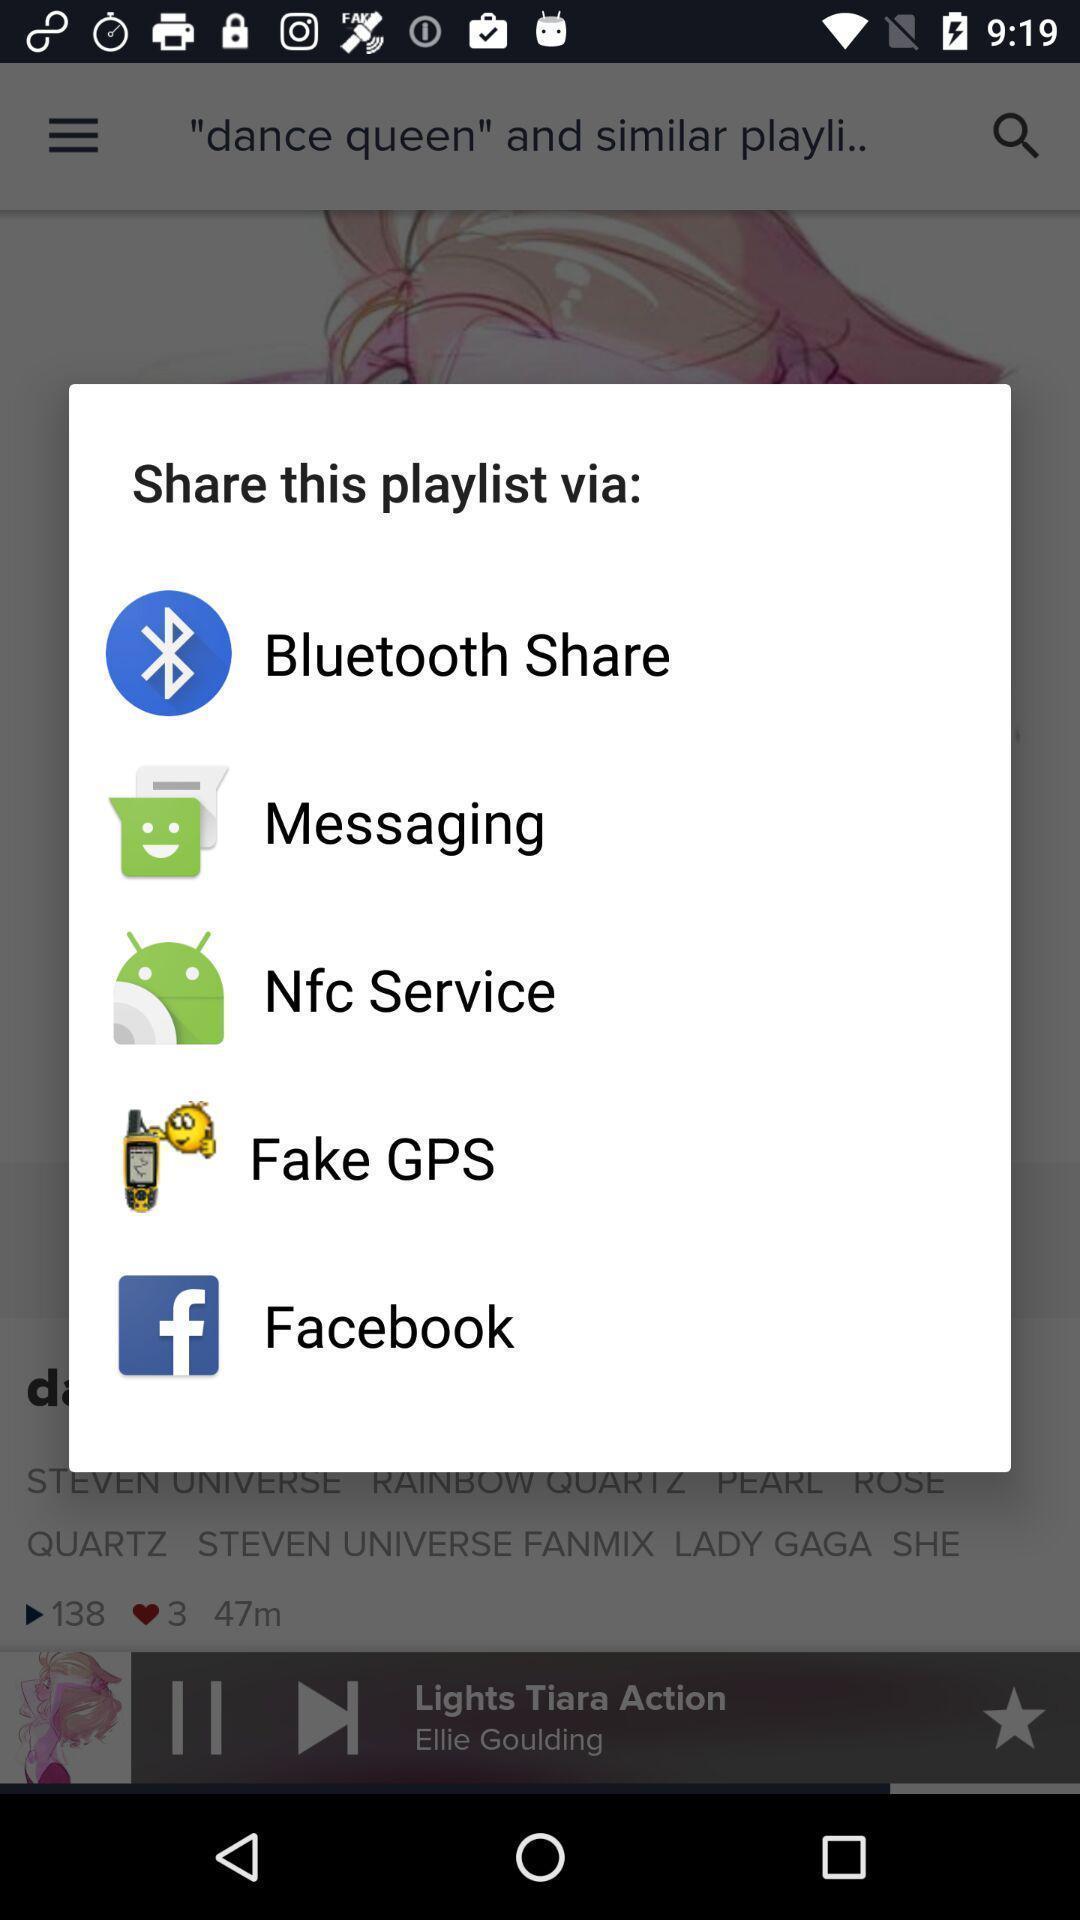Tell me about the visual elements in this screen capture. Pop up page for sharing playlist through different apps. 